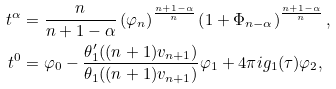<formula> <loc_0><loc_0><loc_500><loc_500>t ^ { \alpha } & = \frac { n } { n + 1 - \alpha } \left ( \varphi _ { n } \right ) ^ { \frac { n + 1 - \alpha } { n } } \left ( 1 + \Phi _ { n - \alpha } \right ) ^ { \frac { n + 1 - \alpha } { n } } , \\ t ^ { 0 } & = \varphi _ { 0 } - \frac { \theta _ { 1 } ^ { \prime } ( ( n + 1 ) v _ { n + 1 } ) } { \theta _ { 1 } ( ( n + 1 ) v _ { n + 1 } ) } \varphi _ { 1 } + 4 \pi i g _ { 1 } ( \tau ) \varphi _ { 2 } ,</formula> 